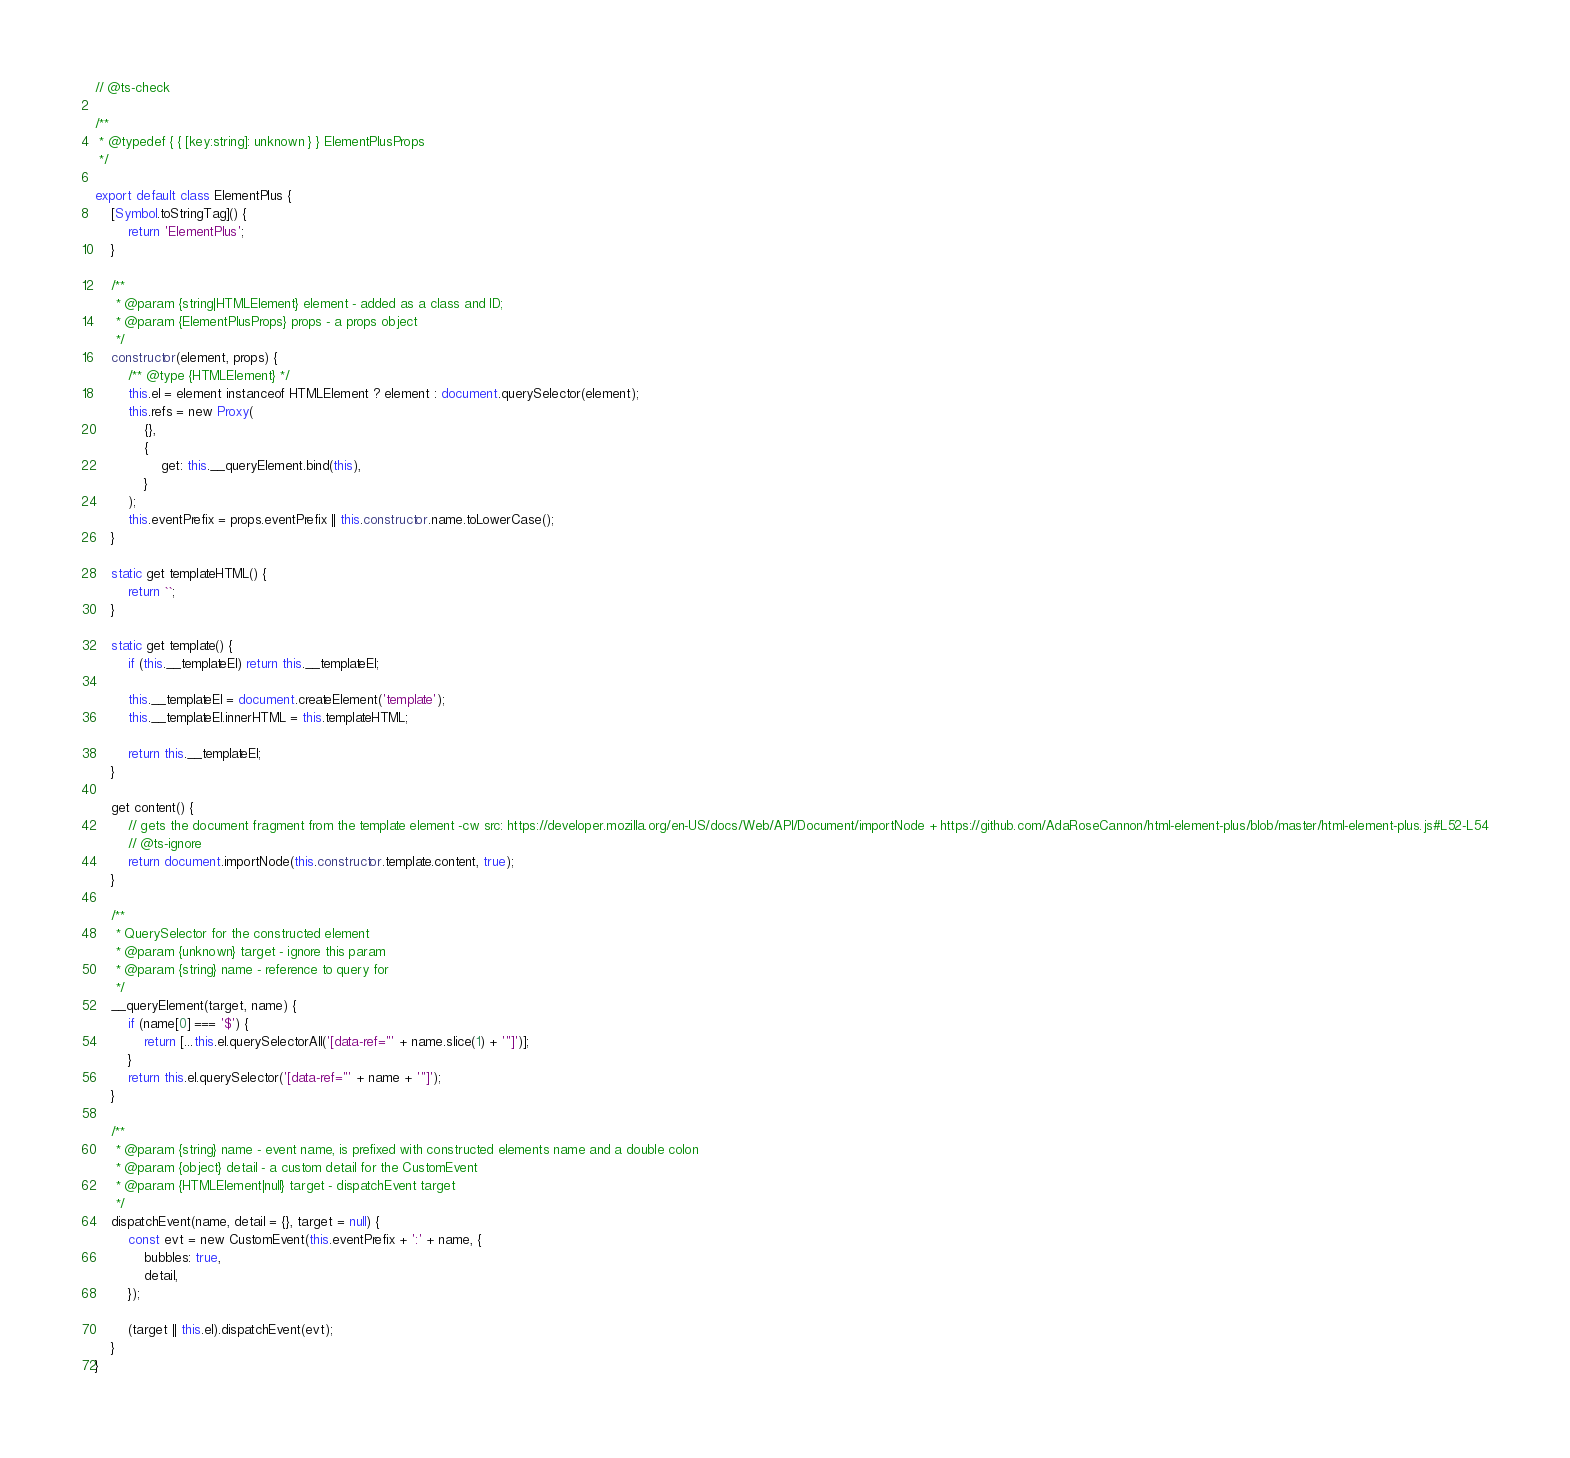<code> <loc_0><loc_0><loc_500><loc_500><_JavaScript_>// @ts-check

/**
 * @typedef { { [key:string]: unknown } } ElementPlusProps
 */

export default class ElementPlus {
	[Symbol.toStringTag]() {
		return 'ElementPlus';
	}

	/**
	 * @param {string|HTMLElement} element - added as a class and ID;
	 * @param {ElementPlusProps} props - a props object
	 */
	constructor(element, props) {
		/** @type {HTMLElement} */
		this.el = element instanceof HTMLElement ? element : document.querySelector(element);
		this.refs = new Proxy(
			{},
			{
				get: this.__queryElement.bind(this),
			}
		);
		this.eventPrefix = props.eventPrefix || this.constructor.name.toLowerCase();
	}

	static get templateHTML() {
		return ``;
	}

	static get template() {
		if (this.__templateEl) return this.__templateEl;

		this.__templateEl = document.createElement('template');
		this.__templateEl.innerHTML = this.templateHTML;

		return this.__templateEl;
	}

	get content() {
		// gets the document fragment from the template element -cw src: https://developer.mozilla.org/en-US/docs/Web/API/Document/importNode + https://github.com/AdaRoseCannon/html-element-plus/blob/master/html-element-plus.js#L52-L54
		// @ts-ignore
		return document.importNode(this.constructor.template.content, true);
	}

	/**
	 * QuerySelector for the constructed element
	 * @param {unknown} target - ignore this param
	 * @param {string} name - reference to query for
	 */
	__queryElement(target, name) {
		if (name[0] === '$') {
			return [...this.el.querySelectorAll('[data-ref="' + name.slice(1) + '"]')];
		}
		return this.el.querySelector('[data-ref="' + name + '"]');
	}

	/**
	 * @param {string} name - event name, is prefixed with constructed elements name and a double colon
	 * @param {object} detail - a custom detail for the CustomEvent
	 * @param {HTMLElement|null} target - dispatchEvent target
	 */
	dispatchEvent(name, detail = {}, target = null) {
		const evt = new CustomEvent(this.eventPrefix + ':' + name, {
			bubbles: true,
			detail,
		});

		(target || this.el).dispatchEvent(evt);
	}
}
</code> 